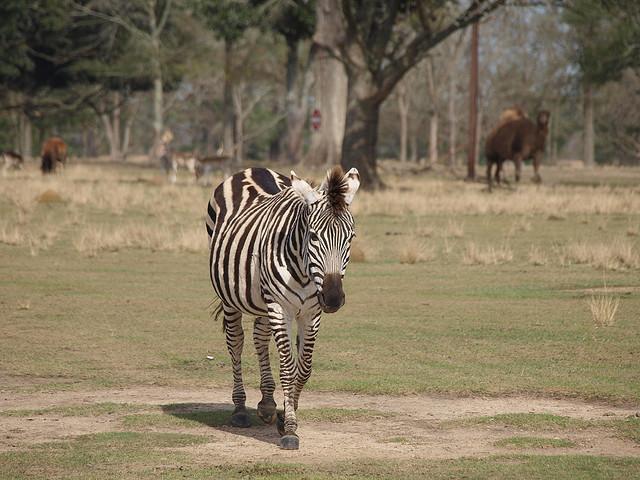How many zebras are there?
Give a very brief answer. 1. How many people are wearing a white shirt?
Give a very brief answer. 0. 